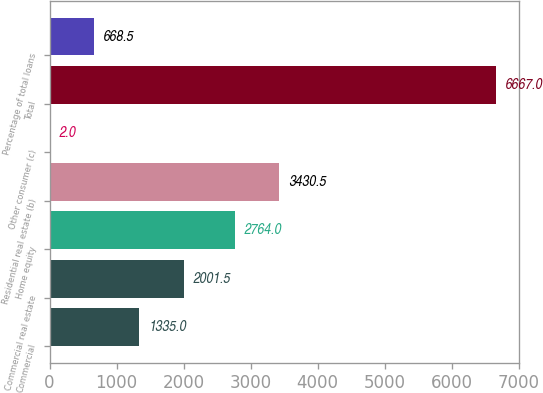Convert chart to OTSL. <chart><loc_0><loc_0><loc_500><loc_500><bar_chart><fcel>Commercial<fcel>Commercial real estate<fcel>Home equity<fcel>Residential real estate (b)<fcel>Other consumer (c)<fcel>Total<fcel>Percentage of total loans<nl><fcel>1335<fcel>2001.5<fcel>2764<fcel>3430.5<fcel>2<fcel>6667<fcel>668.5<nl></chart> 